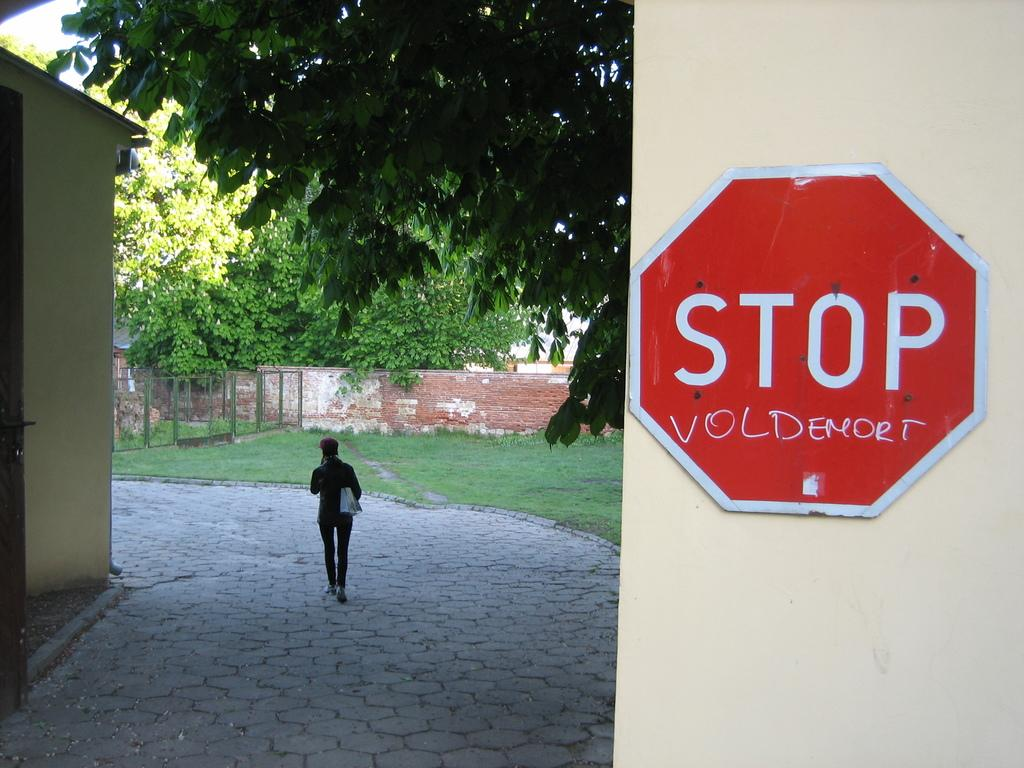What is the person in the image doing? The person is walking in the image. On what surface is the person walking? The person is walking on the floor. What type of vegetation can be seen in the image? There is grass in the image. What architectural feature is present in the image? There is a fence in the image. What type of structure is visible in the image? There are walls in the image. What can be seen in the background of the image? There are trees in the background of the image. How many toes can be seen on the squirrel in the image? There is no squirrel present in the image, so it is not possible to determine the number of toes. 